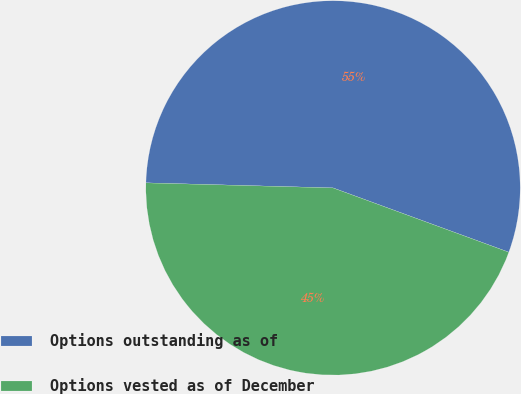Convert chart to OTSL. <chart><loc_0><loc_0><loc_500><loc_500><pie_chart><fcel>Options outstanding as of<fcel>Options vested as of December<nl><fcel>55.15%<fcel>44.85%<nl></chart> 